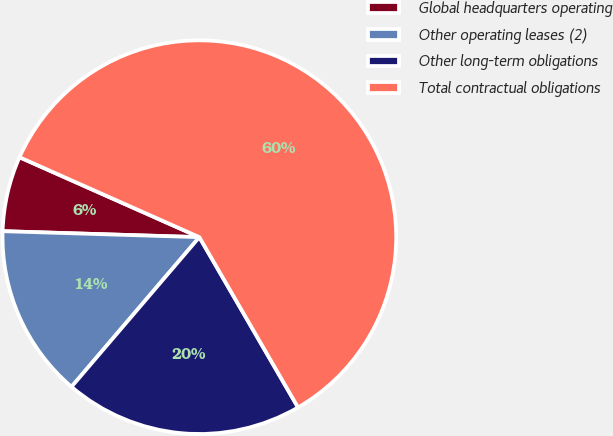Convert chart to OTSL. <chart><loc_0><loc_0><loc_500><loc_500><pie_chart><fcel>Global headquarters operating<fcel>Other operating leases (2)<fcel>Other long-term obligations<fcel>Total contractual obligations<nl><fcel>6.17%<fcel>14.23%<fcel>19.61%<fcel>59.98%<nl></chart> 